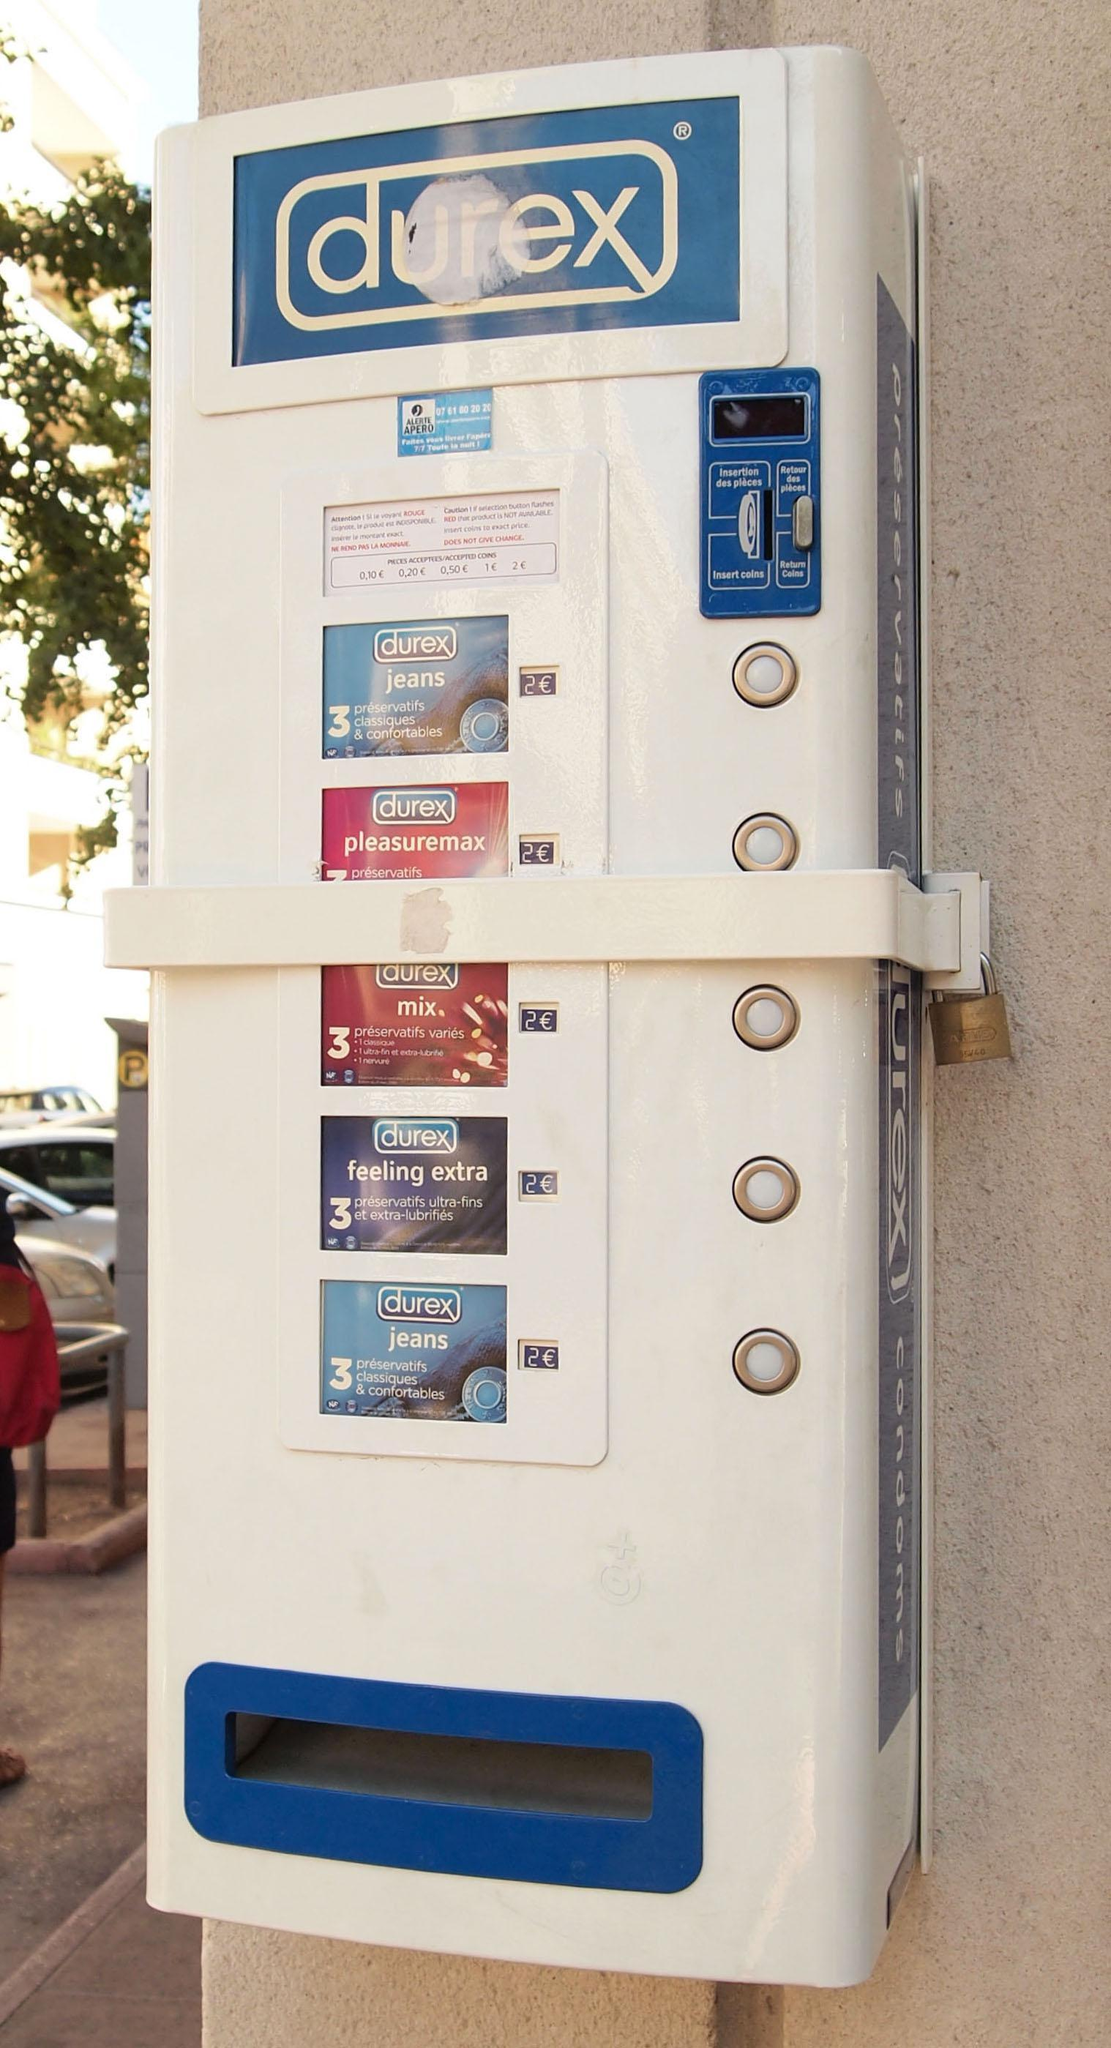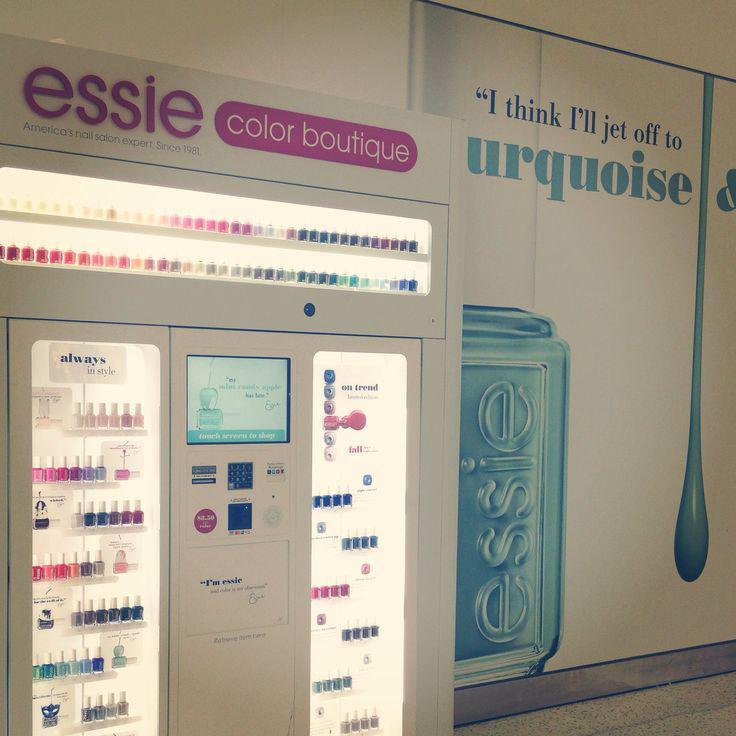The first image is the image on the left, the second image is the image on the right. Given the left and right images, does the statement "One of the machines has a red cross on it." hold true? Answer yes or no. No. The first image is the image on the left, the second image is the image on the right. Assess this claim about the two images: "One of the vending machines sells condoms.". Correct or not? Answer yes or no. Yes. 